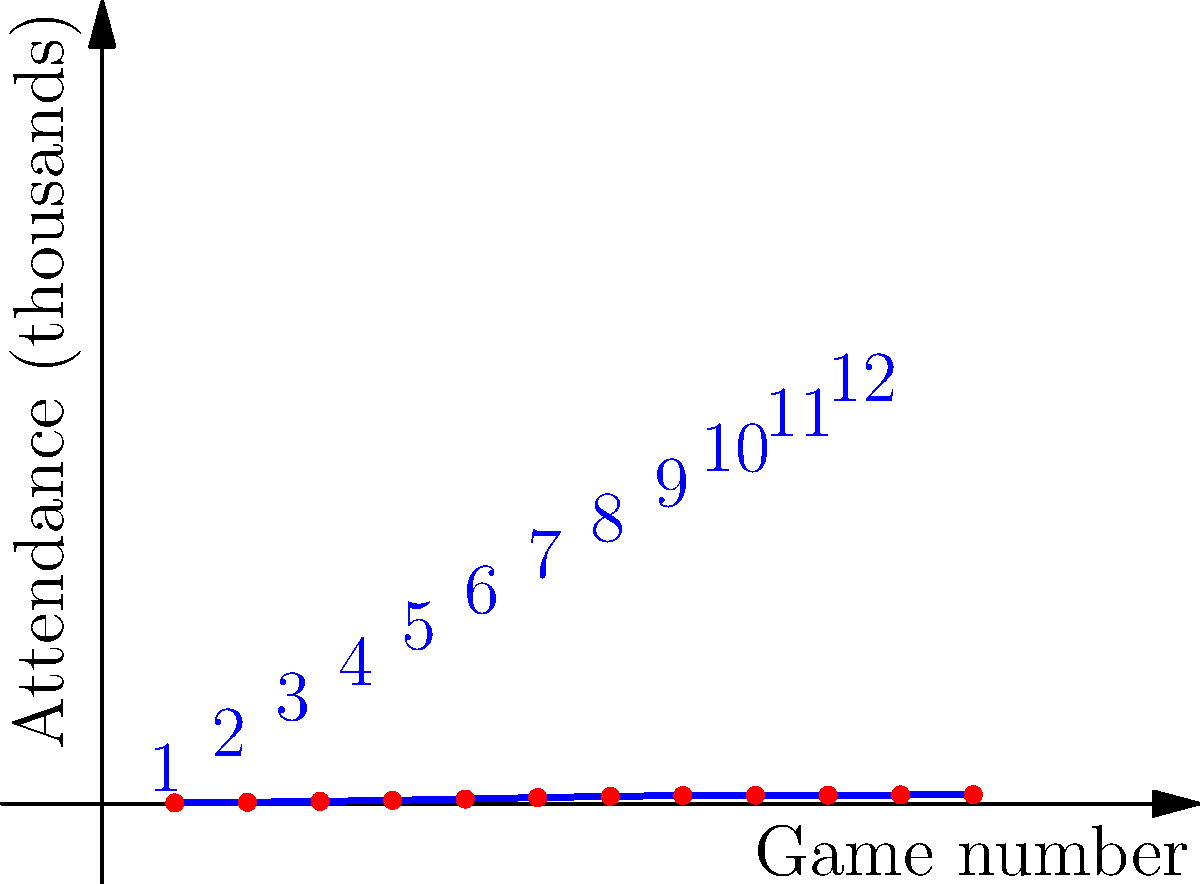In the spiral plot of Bethune-Cookman Wildcats' game attendance data, which game number shows the highest attendance, and what was the approximate attendance for that game? To answer this question, we need to analyze the spiral plot of game attendance data:

1. The spiral plot represents game attendance data for 12 games throughout the season.
2. Each point on the spiral corresponds to a game, with the angle representing the game number and the distance from the center representing the attendance.
3. The game numbers are labeled in blue next to each point.
4. The attendance is represented by the distance from the center, with each unit corresponding to 1,000 attendees.

5. To find the game with the highest attendance:
   - Look for the point farthest from the center of the spiral.
   - This point corresponds to game number 7.

6. To estimate the attendance for game 7:
   - Observe that the point for game 7 is slightly beyond the 14 unit mark from the center.
   - Each unit represents 1,000 attendees.
   - Therefore, the attendance is approximately 14,200.

Thus, game number 7 had the highest attendance with approximately 14,200 spectators.
Answer: Game 7, ~14,200 attendees 